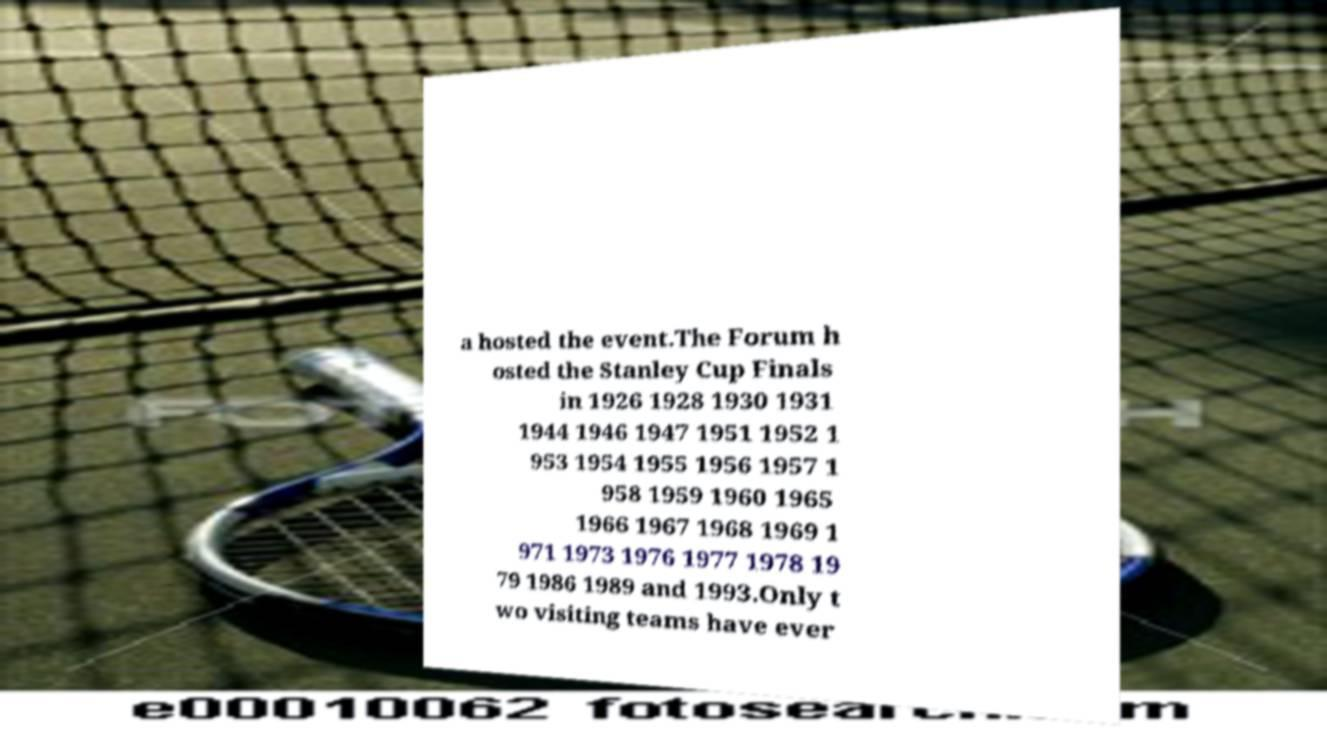Could you assist in decoding the text presented in this image and type it out clearly? a hosted the event.The Forum h osted the Stanley Cup Finals in 1926 1928 1930 1931 1944 1946 1947 1951 1952 1 953 1954 1955 1956 1957 1 958 1959 1960 1965 1966 1967 1968 1969 1 971 1973 1976 1977 1978 19 79 1986 1989 and 1993.Only t wo visiting teams have ever 